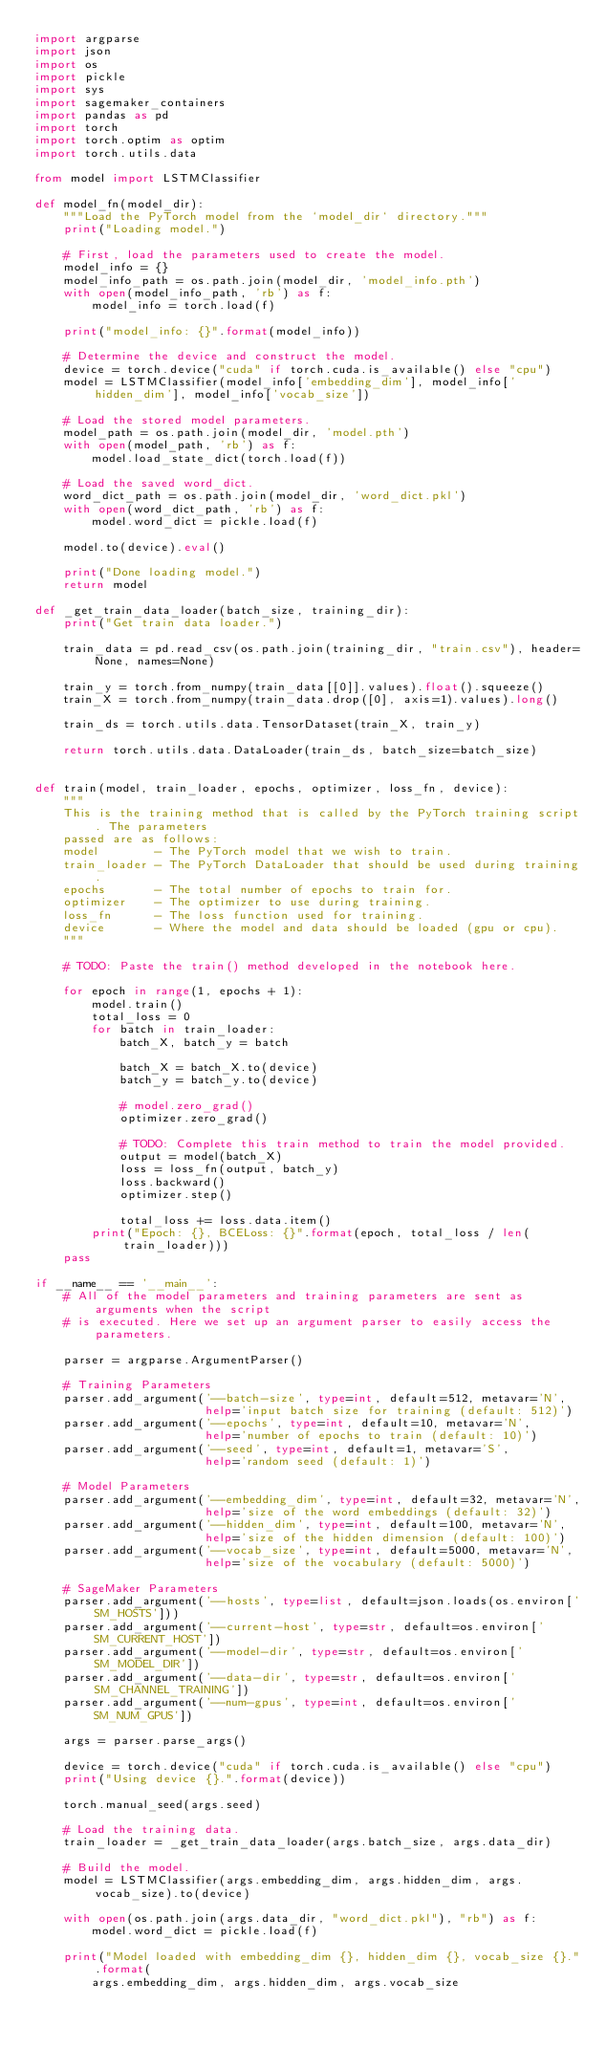Convert code to text. <code><loc_0><loc_0><loc_500><loc_500><_Python_>import argparse
import json
import os
import pickle
import sys
import sagemaker_containers
import pandas as pd
import torch
import torch.optim as optim
import torch.utils.data

from model import LSTMClassifier

def model_fn(model_dir):
    """Load the PyTorch model from the `model_dir` directory."""
    print("Loading model.")

    # First, load the parameters used to create the model.
    model_info = {}
    model_info_path = os.path.join(model_dir, 'model_info.pth')
    with open(model_info_path, 'rb') as f:
        model_info = torch.load(f)

    print("model_info: {}".format(model_info))

    # Determine the device and construct the model.
    device = torch.device("cuda" if torch.cuda.is_available() else "cpu")
    model = LSTMClassifier(model_info['embedding_dim'], model_info['hidden_dim'], model_info['vocab_size'])

    # Load the stored model parameters.
    model_path = os.path.join(model_dir, 'model.pth')
    with open(model_path, 'rb') as f:
        model.load_state_dict(torch.load(f))

    # Load the saved word_dict.
    word_dict_path = os.path.join(model_dir, 'word_dict.pkl')
    with open(word_dict_path, 'rb') as f:
        model.word_dict = pickle.load(f)

    model.to(device).eval()

    print("Done loading model.")
    return model

def _get_train_data_loader(batch_size, training_dir):
    print("Get train data loader.")

    train_data = pd.read_csv(os.path.join(training_dir, "train.csv"), header=None, names=None)

    train_y = torch.from_numpy(train_data[[0]].values).float().squeeze()
    train_X = torch.from_numpy(train_data.drop([0], axis=1).values).long()

    train_ds = torch.utils.data.TensorDataset(train_X, train_y)

    return torch.utils.data.DataLoader(train_ds, batch_size=batch_size)


def train(model, train_loader, epochs, optimizer, loss_fn, device):
    """
    This is the training method that is called by the PyTorch training script. The parameters
    passed are as follows:
    model        - The PyTorch model that we wish to train.
    train_loader - The PyTorch DataLoader that should be used during training.
    epochs       - The total number of epochs to train for.
    optimizer    - The optimizer to use during training.
    loss_fn      - The loss function used for training.
    device       - Where the model and data should be loaded (gpu or cpu).
    """
    
    # TODO: Paste the train() method developed in the notebook here.

    for epoch in range(1, epochs + 1):
        model.train()
        total_loss = 0
        for batch in train_loader:         
            batch_X, batch_y = batch
            
            batch_X = batch_X.to(device)
            batch_y = batch_y.to(device)
            
            # model.zero_grad()
            optimizer.zero_grad()
            
            # TODO: Complete this train method to train the model provided.
            output = model(batch_X)
            loss = loss_fn(output, batch_y)
            loss.backward()
            optimizer.step()
            
            total_loss += loss.data.item()
        print("Epoch: {}, BCELoss: {}".format(epoch, total_loss / len(train_loader)))
    pass

if __name__ == '__main__':
    # All of the model parameters and training parameters are sent as arguments when the script
    # is executed. Here we set up an argument parser to easily access the parameters.

    parser = argparse.ArgumentParser()

    # Training Parameters
    parser.add_argument('--batch-size', type=int, default=512, metavar='N',
                        help='input batch size for training (default: 512)')
    parser.add_argument('--epochs', type=int, default=10, metavar='N',
                        help='number of epochs to train (default: 10)')
    parser.add_argument('--seed', type=int, default=1, metavar='S',
                        help='random seed (default: 1)')

    # Model Parameters
    parser.add_argument('--embedding_dim', type=int, default=32, metavar='N',
                        help='size of the word embeddings (default: 32)')
    parser.add_argument('--hidden_dim', type=int, default=100, metavar='N',
                        help='size of the hidden dimension (default: 100)')
    parser.add_argument('--vocab_size', type=int, default=5000, metavar='N',
                        help='size of the vocabulary (default: 5000)')

    # SageMaker Parameters
    parser.add_argument('--hosts', type=list, default=json.loads(os.environ['SM_HOSTS']))
    parser.add_argument('--current-host', type=str, default=os.environ['SM_CURRENT_HOST'])
    parser.add_argument('--model-dir', type=str, default=os.environ['SM_MODEL_DIR'])
    parser.add_argument('--data-dir', type=str, default=os.environ['SM_CHANNEL_TRAINING'])
    parser.add_argument('--num-gpus', type=int, default=os.environ['SM_NUM_GPUS'])

    args = parser.parse_args()

    device = torch.device("cuda" if torch.cuda.is_available() else "cpu")
    print("Using device {}.".format(device))

    torch.manual_seed(args.seed)

    # Load the training data.
    train_loader = _get_train_data_loader(args.batch_size, args.data_dir)

    # Build the model.
    model = LSTMClassifier(args.embedding_dim, args.hidden_dim, args.vocab_size).to(device)

    with open(os.path.join(args.data_dir, "word_dict.pkl"), "rb") as f:
        model.word_dict = pickle.load(f)

    print("Model loaded with embedding_dim {}, hidden_dim {}, vocab_size {}.".format(
        args.embedding_dim, args.hidden_dim, args.vocab_size</code> 